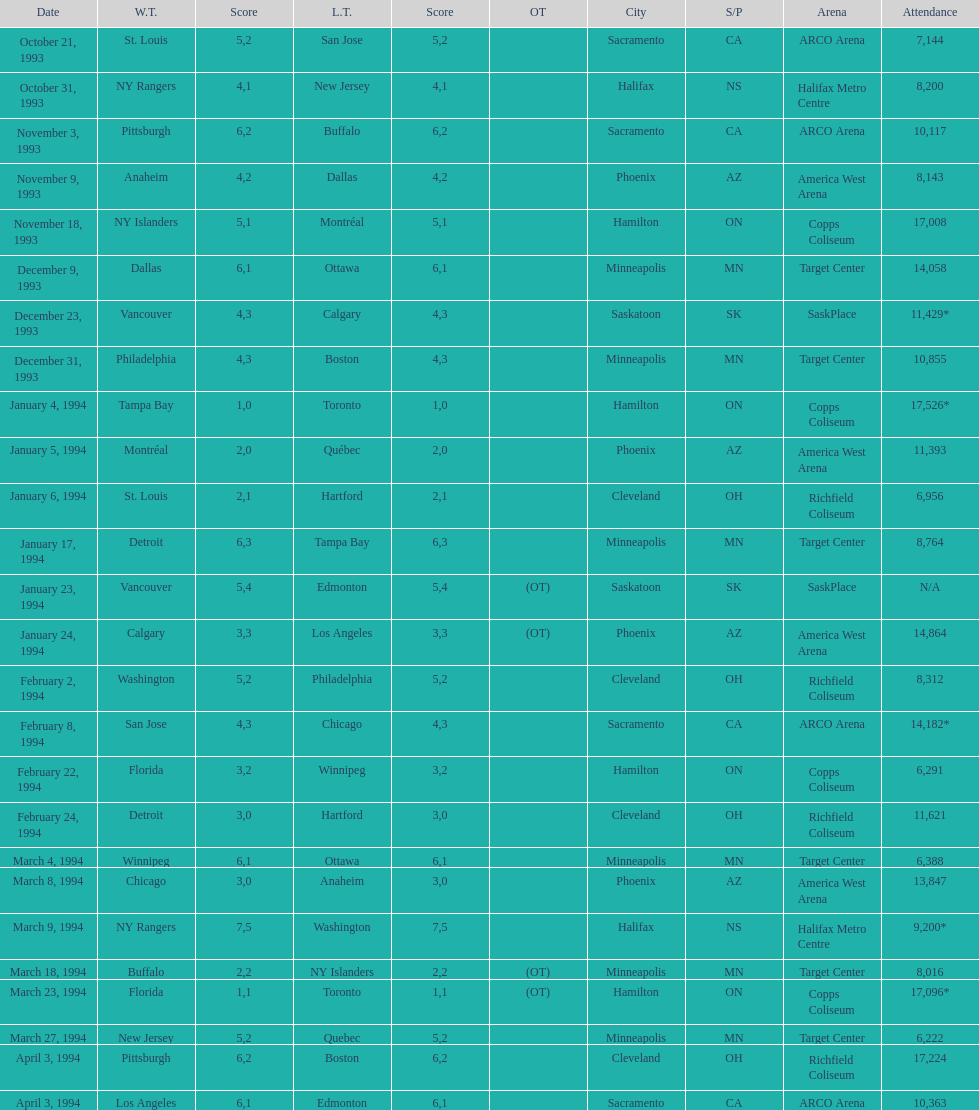Which event had higher attendance, january 24, 1994, or december 23, 1993? January 4, 1994. 